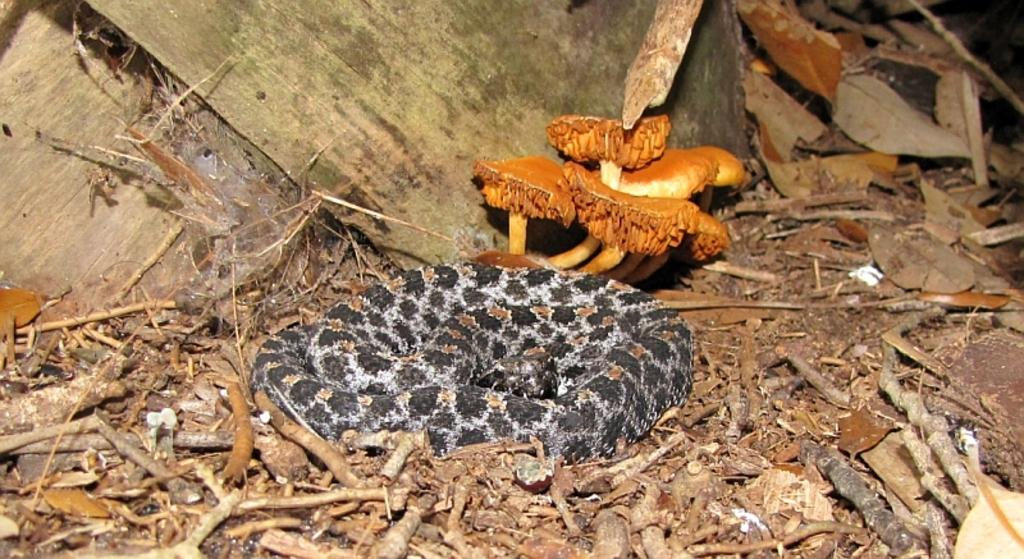What is the main subject in the center of the image? There is a snake in the center of the image. What other objects can be seen in the image? There are mushrooms in the image. What is located at the bottom of the image? There are twigs at the bottom of the image. What type of vegetation is present in the image? Leaves are visible in the image. Where is the art displayed in the image? There is no art displayed in the image; it features a snake, mushrooms, twigs, and leaves. What type of dolls can be seen interacting with the snake in the image? There are no dolls present in the image. 